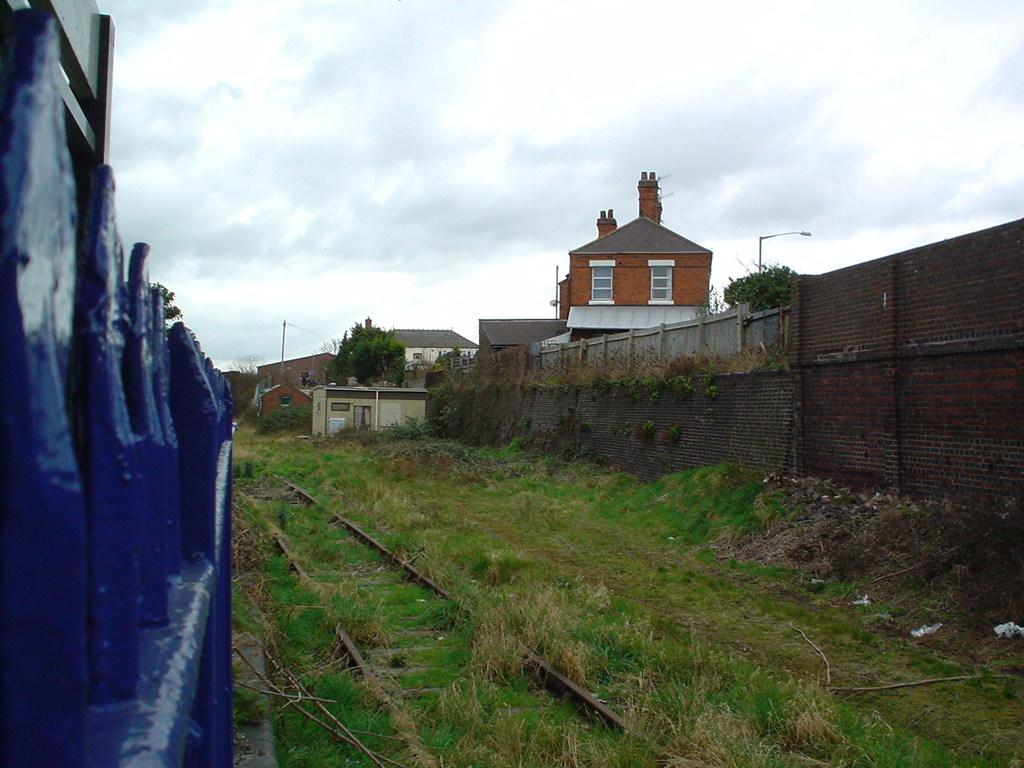What type of vegetation can be seen in the image? There is grass in the image, and it is green. What can be seen in the distance in the image? There are buildings in the background of the image. What are the tall, vertical structures in the background of the image? Light poles are present in the background of the image. What is visible above the grass and buildings in the image? The sky is visible in the image, and it has a white and blue color. What type of tooth is visible in the image? There is no tooth present in the image. What angle is the image taken from? The angle from which the image is taken is not mentioned in the provided facts. 